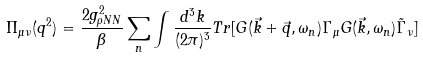<formula> <loc_0><loc_0><loc_500><loc_500>\Pi _ { \mu \nu } ( q ^ { 2 } ) = \frac { 2 g ^ { 2 } _ { \rho N N } } { \beta } \sum _ { n } \int \frac { d ^ { 3 } k } { ( 2 \pi ) ^ { 3 } } T r [ G ( \vec { k } + \vec { q } , \omega _ { n } ) \Gamma _ { \mu } G ( \vec { k } , \omega _ { n } ) \tilde { \Gamma } _ { \nu } ]</formula> 